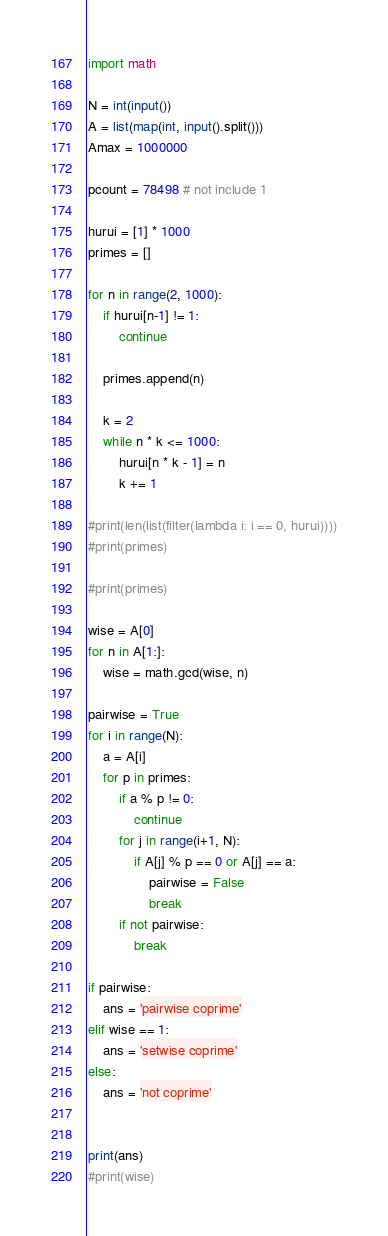<code> <loc_0><loc_0><loc_500><loc_500><_Python_>import math

N = int(input())
A = list(map(int, input().split()))
Amax = 1000000

pcount = 78498 # not include 1

hurui = [1] * 1000
primes = []

for n in range(2, 1000):
    if hurui[n-1] != 1:
        continue

    primes.append(n)

    k = 2
    while n * k <= 1000:
        hurui[n * k - 1] = n
        k += 1

#print(len(list(filter(lambda i: i == 0, hurui))))
#print(primes)

#print(primes)

wise = A[0]
for n in A[1:]:
    wise = math.gcd(wise, n)

pairwise = True
for i in range(N):
    a = A[i]
    for p in primes:
        if a % p != 0:
            continue
        for j in range(i+1, N):
            if A[j] % p == 0 or A[j] == a:
                pairwise = False
                break
        if not pairwise:
            break

if pairwise:
    ans = 'pairwise coprime'
elif wise == 1:
    ans = 'setwise coprime'
else:
    ans = 'not coprime'


print(ans)
#print(wise)</code> 